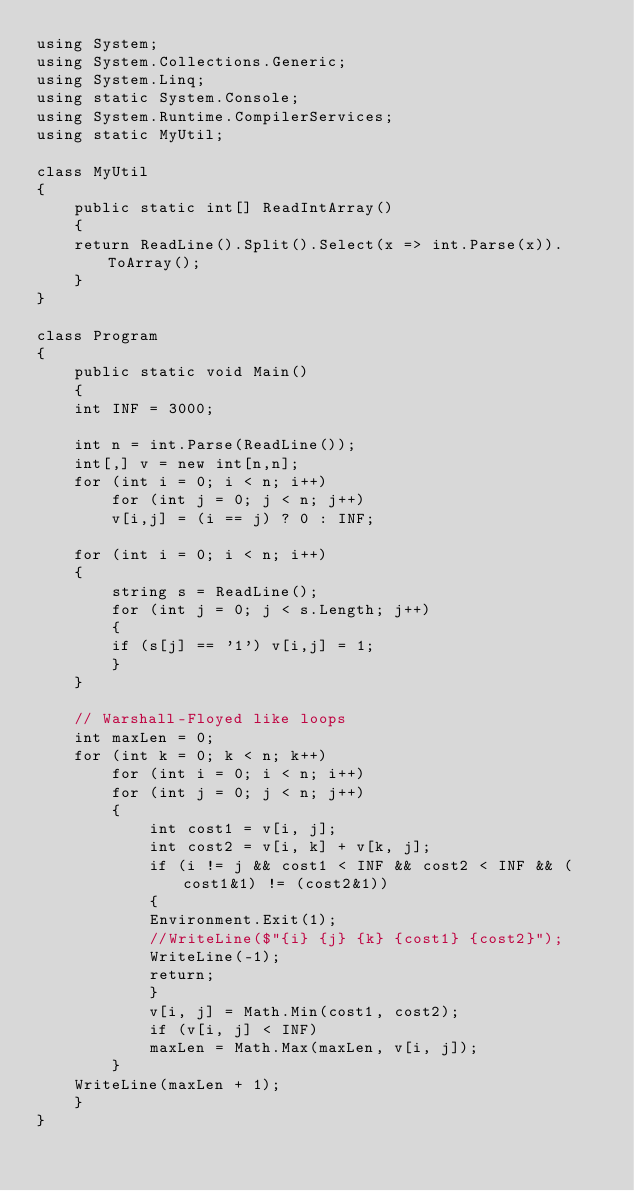Convert code to text. <code><loc_0><loc_0><loc_500><loc_500><_C#_>using System;
using System.Collections.Generic;
using System.Linq;
using static System.Console;
using System.Runtime.CompilerServices;
using static MyUtil;

class MyUtil
{
    public static int[] ReadIntArray()
    {
	return ReadLine().Split().Select(x => int.Parse(x)).ToArray();
    }
}

class Program
{
    public static void Main()
    {
	int INF = 3000;
	
	int n = int.Parse(ReadLine());
	int[,] v = new int[n,n];
	for (int i = 0; i < n; i++)
	    for (int j = 0; j < n; j++)
		v[i,j] = (i == j) ? 0 : INF;

	for (int i = 0; i < n; i++)
	{
	    string s = ReadLine();
	    for (int j = 0; j < s.Length; j++)
	    {
		if (s[j] == '1') v[i,j] = 1;
	    }
	}

	// Warshall-Floyed like loops
	int maxLen = 0;
	for (int k = 0; k < n; k++)
	    for (int i = 0; i < n; i++)
		for (int j = 0; j < n; j++)
		{
		    int cost1 = v[i, j];
		    int cost2 = v[i, k] + v[k, j];
		    if (i != j && cost1 < INF && cost2 < INF && (cost1&1) != (cost2&1))
		    {
			Environment.Exit(1);
			//WriteLine($"{i} {j} {k} {cost1} {cost2}");
			WriteLine(-1);
			return;
		    }
		    v[i, j] = Math.Min(cost1, cost2);
		    if (v[i, j] < INF)
			maxLen = Math.Max(maxLen, v[i, j]);
		}
	WriteLine(maxLen + 1);
    }
}
</code> 